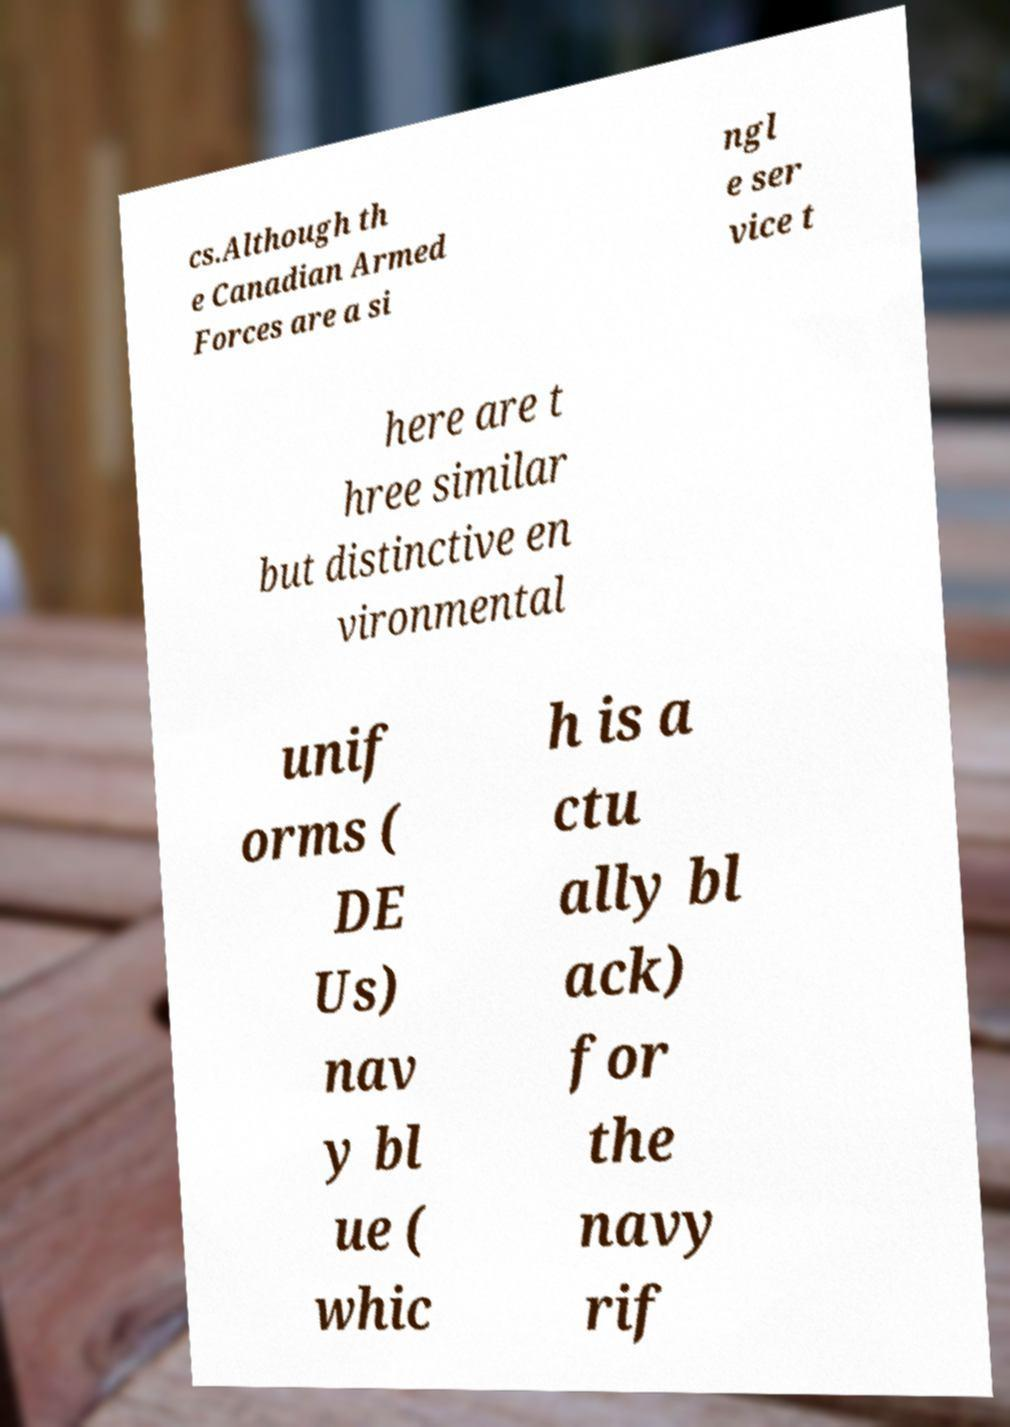There's text embedded in this image that I need extracted. Can you transcribe it verbatim? cs.Although th e Canadian Armed Forces are a si ngl e ser vice t here are t hree similar but distinctive en vironmental unif orms ( DE Us) nav y bl ue ( whic h is a ctu ally bl ack) for the navy rif 